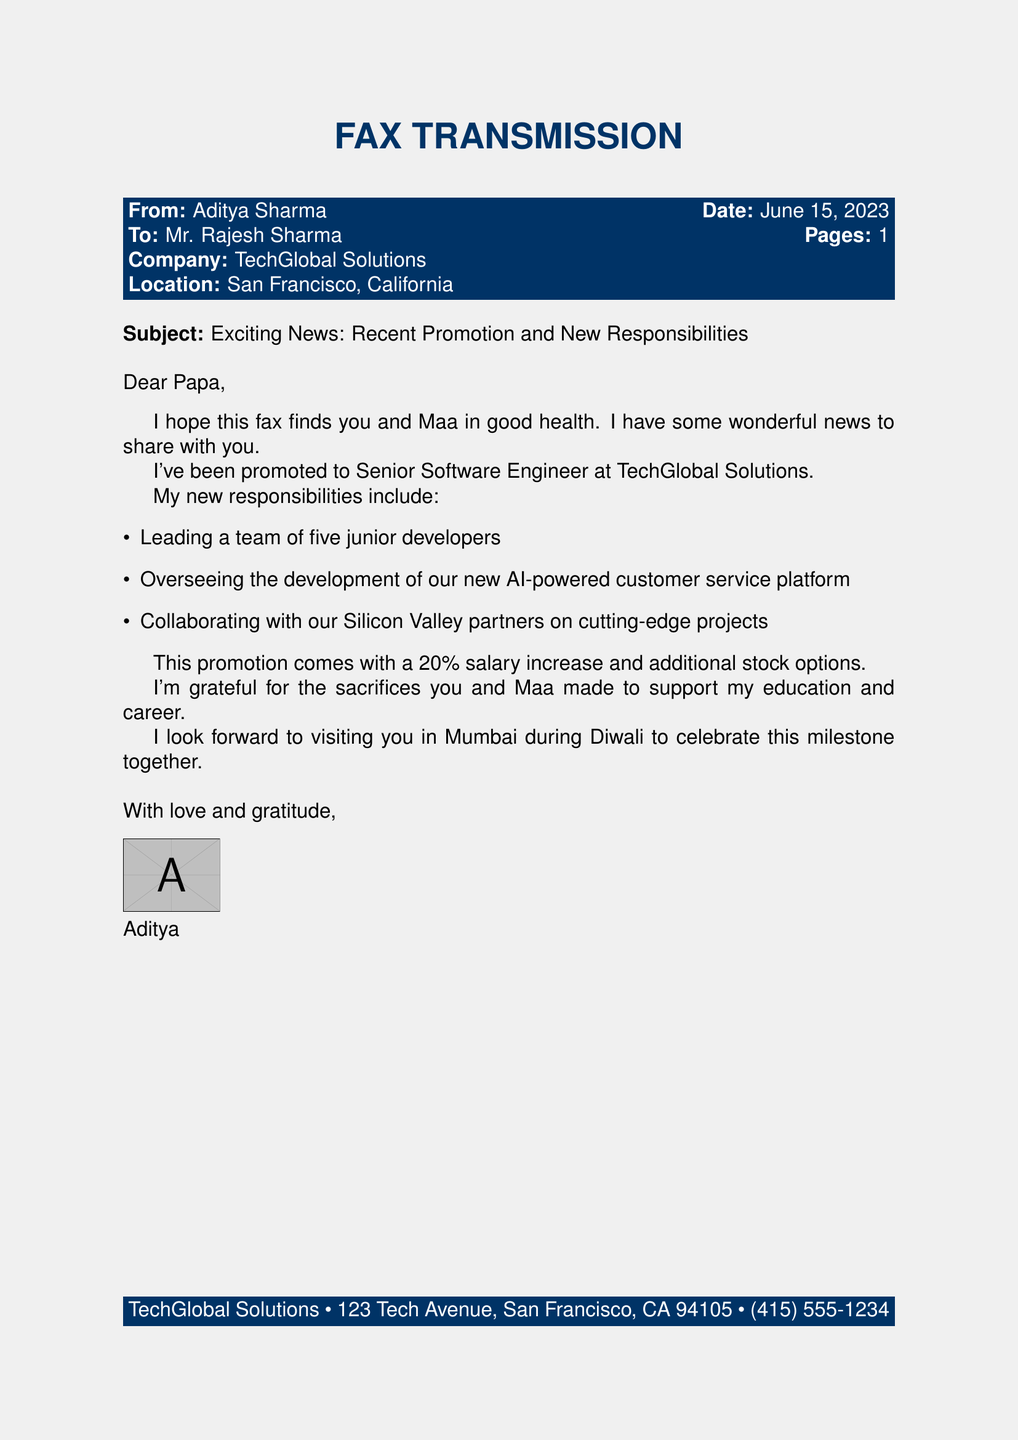What is the sender's name? The sender is identified at the top of the fax as Aditya Sharma.
Answer: Aditya Sharma What is the recipient's name? The recipient is mentioned as Mr. Rajesh Sharma in the fax header.
Answer: Mr. Rajesh Sharma What is the new job title of Aditya? The document states that Aditya has been promoted to Senior Software Engineer.
Answer: Senior Software Engineer By how much has Aditya's salary increased? The fax specifies that his salary has increased by 20 percent.
Answer: 20 percent What is one of Aditya's new responsibilities? The document lists several responsibilities, one of which is leading a team of five junior developers.
Answer: Leading a team of five junior developers What milestone does Aditya plan to celebrate with his parents? He mentions he wants to celebrate his promotion during Diwali.
Answer: Diwali Where is Aditya's company located? The fax provides the company address as San Francisco, California.
Answer: San Francisco, California When was the fax sent? The date on the fax indicates it was sent on June 15, 2023.
Answer: June 15, 2023 How many junior developers will Aditya be leading? The document mentions he will be leading a team of five junior developers.
Answer: Five junior developers 